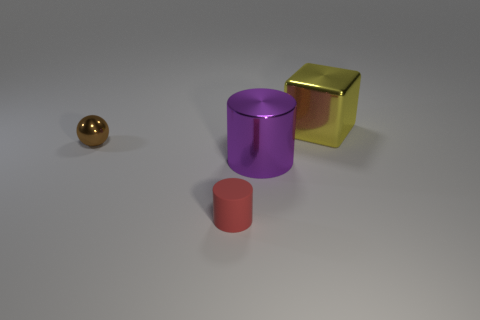There is a tiny shiny object; what number of big yellow cubes are behind it?
Ensure brevity in your answer.  1. Is the number of yellow shiny objects left of the big yellow thing the same as the number of tiny objects that are behind the rubber object?
Give a very brief answer. No. There is a tiny thing that is in front of the shiny sphere; is it the same shape as the purple metal thing?
Your answer should be compact. Yes. Are there any other things that have the same material as the tiny red cylinder?
Your answer should be compact. No. Do the metal cylinder and the yellow metallic cube that is right of the red matte object have the same size?
Keep it short and to the point. Yes. There is a rubber thing; are there any brown objects on the right side of it?
Keep it short and to the point. No. What number of objects are tiny things or tiny rubber things left of the shiny cube?
Make the answer very short. 2. Is there a object in front of the large object in front of the large yellow shiny cube?
Give a very brief answer. Yes. What shape is the large object that is to the left of the big metal thing that is on the right side of the large thing that is in front of the big cube?
Provide a succinct answer. Cylinder. There is a metallic object that is on the right side of the rubber object and left of the yellow metal block; what color is it?
Ensure brevity in your answer.  Purple. 